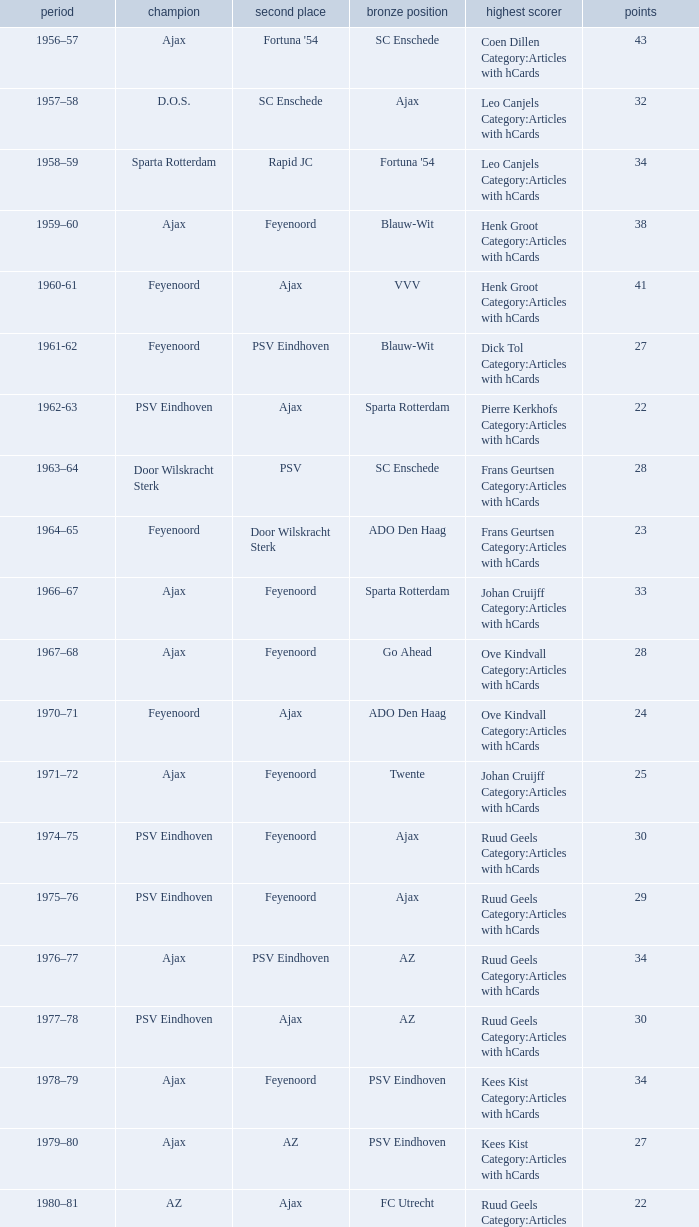When nac breda came in third place and psv eindhoven was the winner who is the top scorer? Klaas-Jan Huntelaar Category:Articles with hCards. 